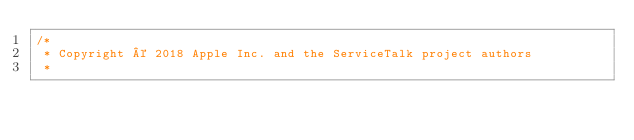<code> <loc_0><loc_0><loc_500><loc_500><_Java_>/*
 * Copyright © 2018 Apple Inc. and the ServiceTalk project authors
 *</code> 